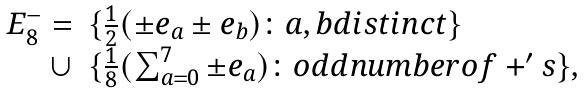<formula> <loc_0><loc_0><loc_500><loc_500>\begin{array} { r l } E _ { 8 } ^ { - } = & \{ \frac { 1 } { 2 } ( \pm e _ { a } \pm e _ { b } ) \colon a , b d i s t i n c t \} \\ \cup & \{ \frac { 1 } { 8 } ( \sum _ { a = 0 } ^ { 7 } \pm e _ { a } ) \colon o d d n u m b e r o f + ^ { \prime } s \} , \\ \\ \end{array}</formula> 